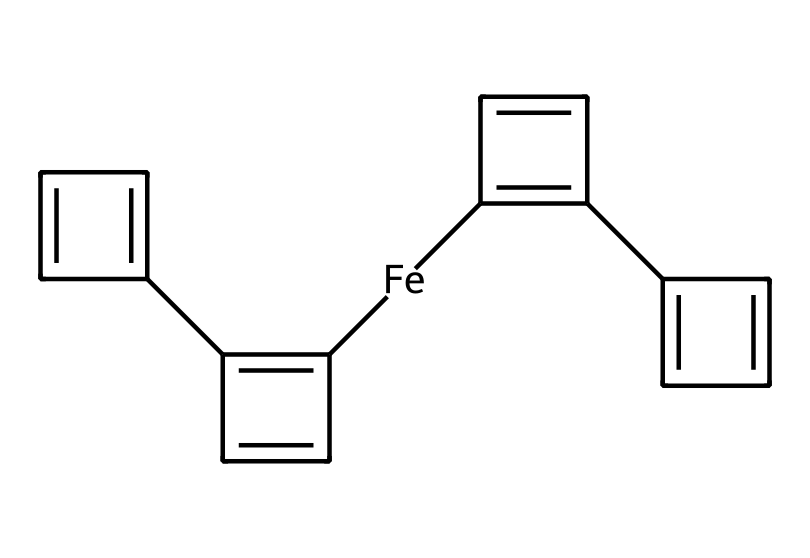What is the central metal atom in this coordination compound? The SMILES representation includes [Fe], indicating that iron is the central metal atom in the coordination structure.
Answer: iron How many cyclopentadienyl ligands are coordinated to the iron? The SMILES shows multiple instances of cyclopentadienyl and each is depicted with the structure C1=C, which represents a cyclopentadienyl ligand. There are two in this structure, therefore the count is two.
Answer: two What type of bonding primarily exists between iron and the cyclopentadienyl ligands? The bonding between the iron and the coordinated cyclopentadienyl ligands is characterized as sigma bonding, which occurs due to the overlap of orbitals between the central metal and the p orbitals of the aromatic rings.
Answer: sigma bonding What is the hybridization of the central metal in ferrocene? The central iron atom exhibits sp2 hybridization due to its coordination and bonding with the two cyclopentadienyl ligands, which requires the iron to utilize these hybrid orbitals for bonding.
Answer: sp2 How does the electronic structure of ferrocene contribute to its stability? Ferrocene's stability arises from its unique sandwich structure formed by the planar cyclopentadienyl ligands, which helps stabilize the iron in the middle. This electronic configuration, in conjunction with resonance in the ligands, enhances overall stability.
Answer: sandwich structure In which applications is ferrocene used as a catalyst? Ferrocene is commonly used as a catalyst in polymerization processes and as an additive to enhance the efficiency and performance of fuels due to its ability to stabilize free radicals.
Answer: polymerization processes 